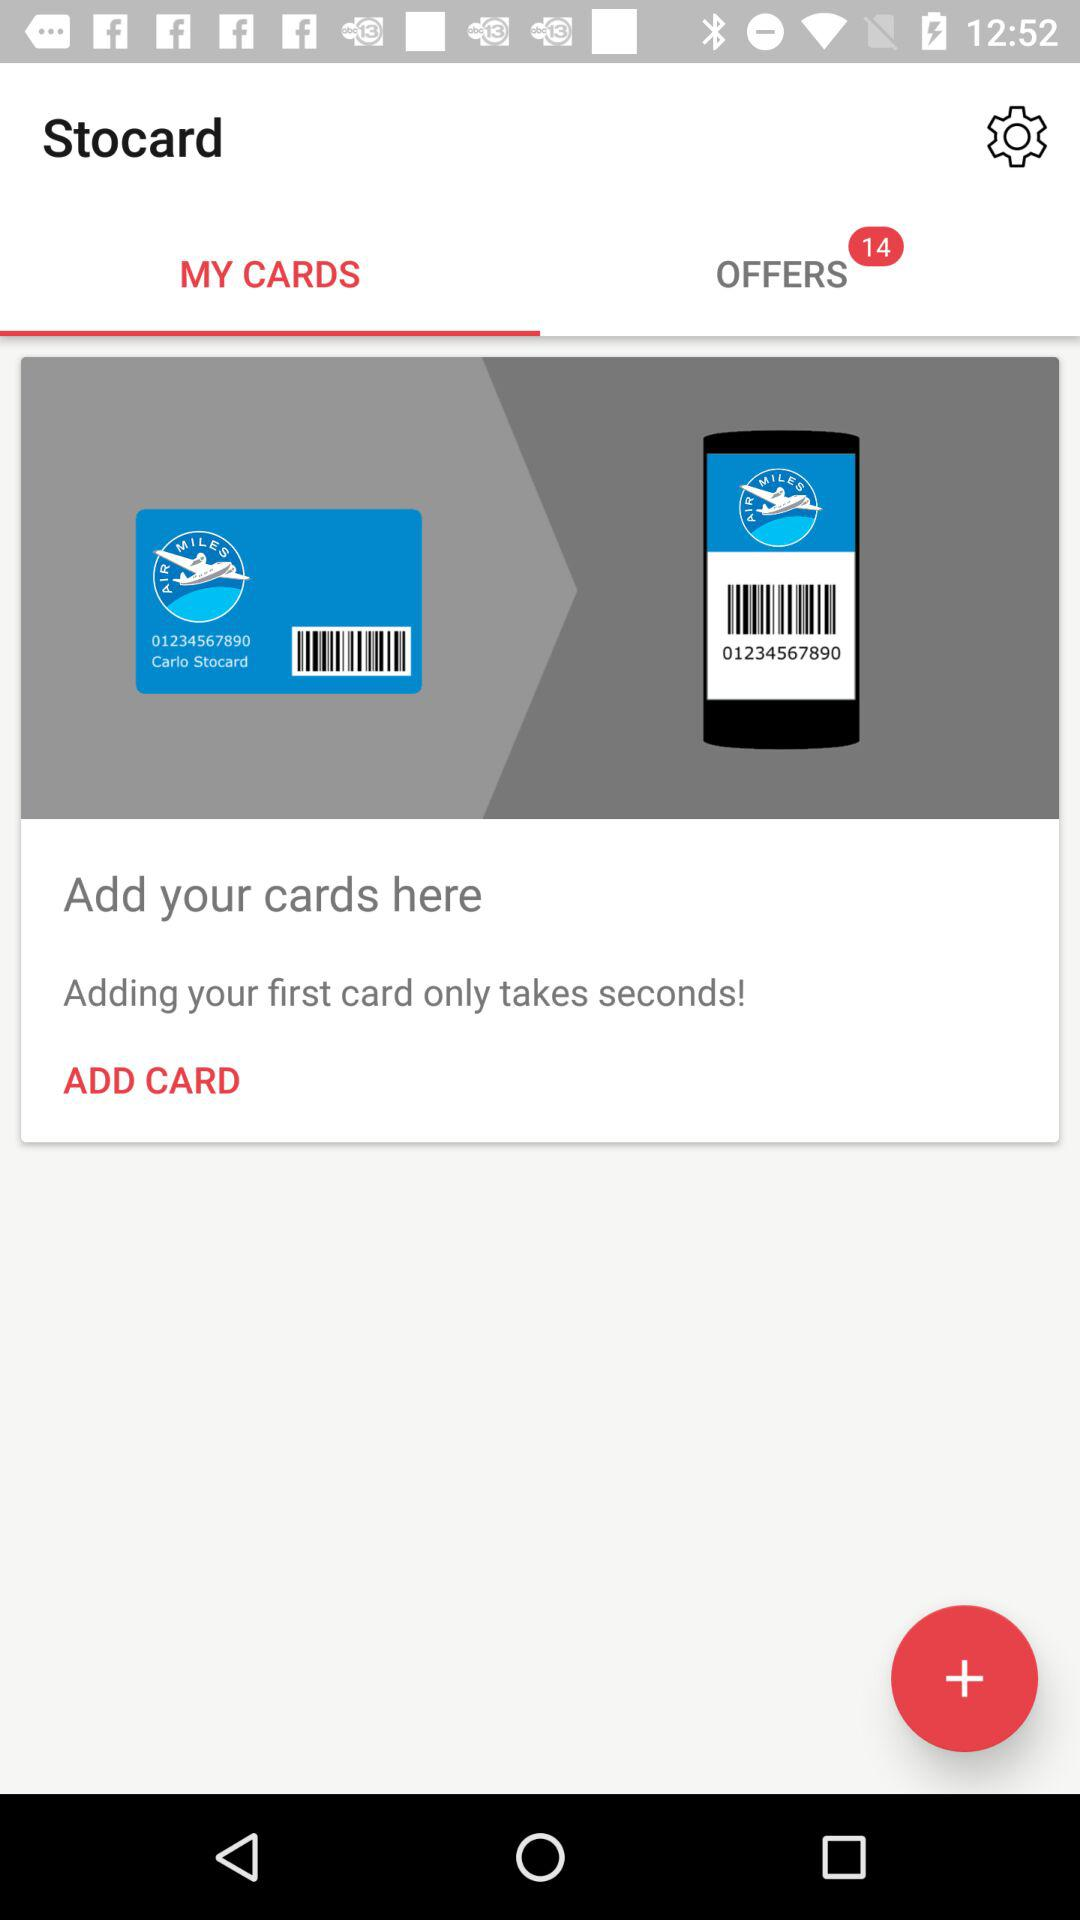What is the application name? The application name is "Stocard". 